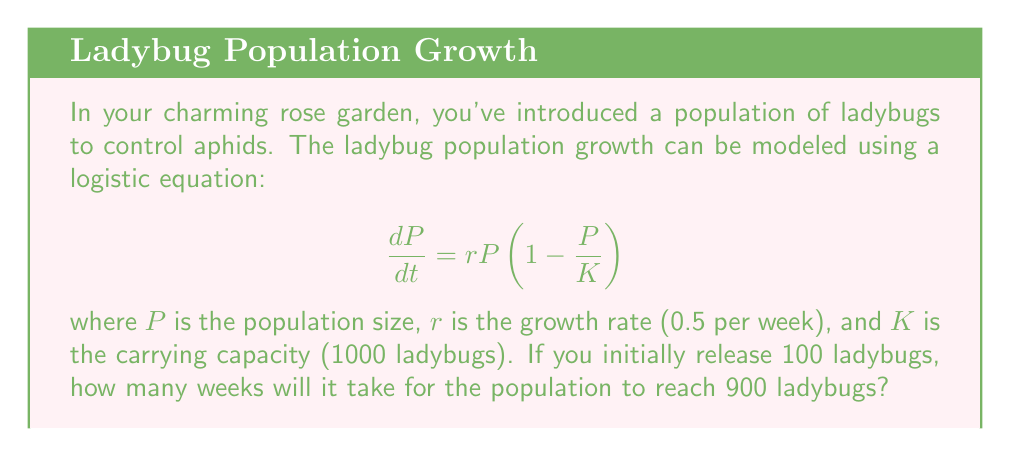Solve this math problem. To solve this problem, we'll use the analytical solution of the logistic equation:

$$P(t) = \frac{K}{1 + (\frac{K}{P_0} - 1)e^{-rt}}$$

Where:
$P(t)$ is the population at time $t$
$K$ = 1000 (carrying capacity)
$P_0$ = 100 (initial population)
$r$ = 0.5 (growth rate per week)

We want to find $t$ when $P(t) = 900$. Let's substitute these values:

$$900 = \frac{1000}{1 + (\frac{1000}{100} - 1)e^{-0.5t}}$$

Now, let's solve for $t$:

1) Multiply both sides by the denominator:
   $$900(1 + 9e^{-0.5t}) = 1000$$

2) Divide both sides by 900:
   $$1 + 9e^{-0.5t} = \frac{10}{9}$$

3) Subtract 1 from both sides:
   $$9e^{-0.5t} = \frac{1}{9}$$

4) Divide both sides by 9:
   $$e^{-0.5t} = \frac{1}{81}$$

5) Take the natural log of both sides:
   $$-0.5t = \ln(\frac{1}{81}) = -\ln(81)$$

6) Divide both sides by -0.5:
   $$t = \frac{\ln(81)}{0.5} = 2\ln(81) \approx 8.78$$

Therefore, it will take approximately 8.78 weeks for the ladybug population to reach 900.
Answer: 8.78 weeks 